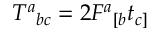Convert formula to latex. <formula><loc_0><loc_0><loc_500><loc_500>T ^ { a _ { b c } = 2 F ^ { a _ { [ b } t _ { c ] }</formula> 